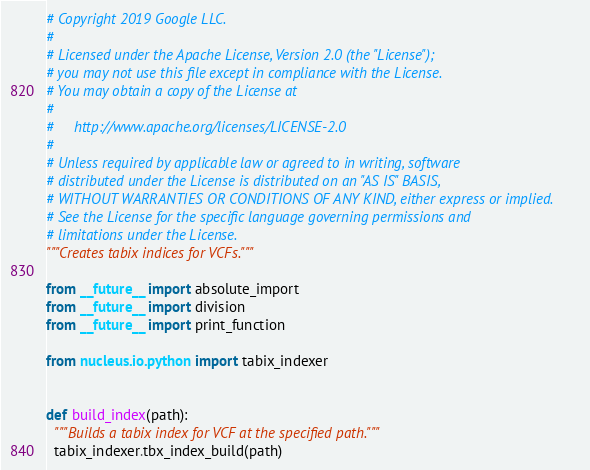<code> <loc_0><loc_0><loc_500><loc_500><_Python_># Copyright 2019 Google LLC.
#
# Licensed under the Apache License, Version 2.0 (the "License");
# you may not use this file except in compliance with the License.
# You may obtain a copy of the License at
#
#     http://www.apache.org/licenses/LICENSE-2.0
#
# Unless required by applicable law or agreed to in writing, software
# distributed under the License is distributed on an "AS IS" BASIS,
# WITHOUT WARRANTIES OR CONDITIONS OF ANY KIND, either express or implied.
# See the License for the specific language governing permissions and
# limitations under the License.
"""Creates tabix indices for VCFs."""

from __future__ import absolute_import
from __future__ import division
from __future__ import print_function

from nucleus.io.python import tabix_indexer


def build_index(path):
  """Builds a tabix index for VCF at the specified path."""
  tabix_indexer.tbx_index_build(path)
</code> 